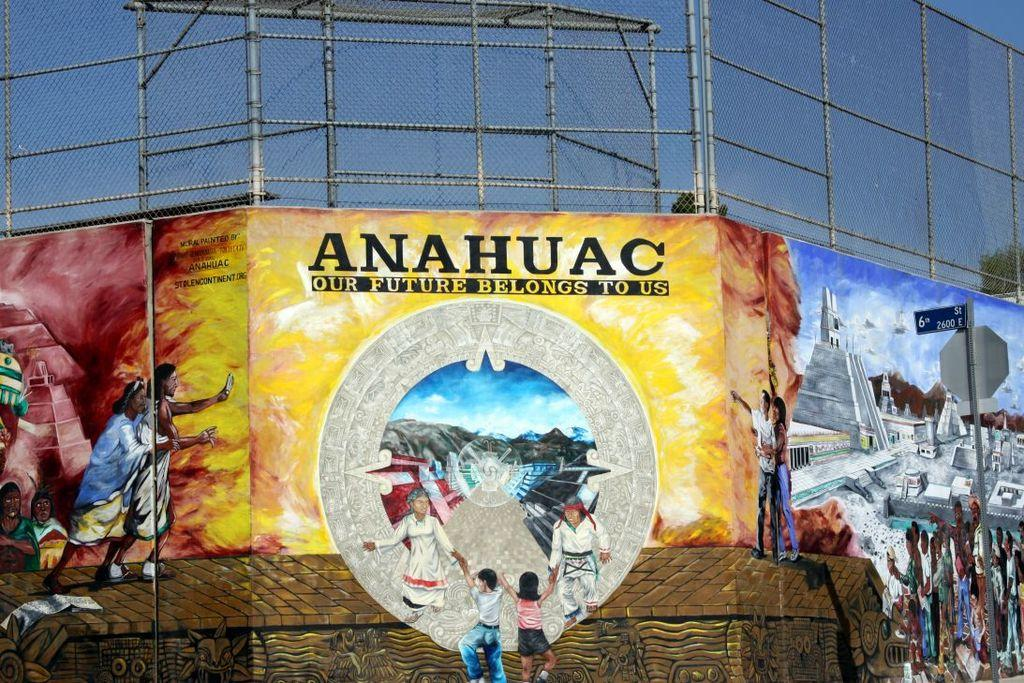<image>
Share a concise interpretation of the image provided. some people standing in front of a anuhuac sign 